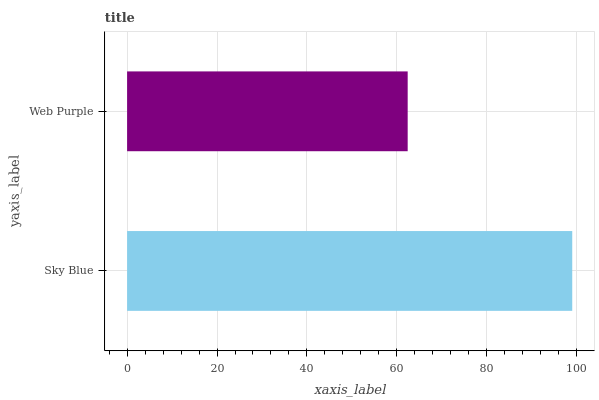Is Web Purple the minimum?
Answer yes or no. Yes. Is Sky Blue the maximum?
Answer yes or no. Yes. Is Web Purple the maximum?
Answer yes or no. No. Is Sky Blue greater than Web Purple?
Answer yes or no. Yes. Is Web Purple less than Sky Blue?
Answer yes or no. Yes. Is Web Purple greater than Sky Blue?
Answer yes or no. No. Is Sky Blue less than Web Purple?
Answer yes or no. No. Is Sky Blue the high median?
Answer yes or no. Yes. Is Web Purple the low median?
Answer yes or no. Yes. Is Web Purple the high median?
Answer yes or no. No. Is Sky Blue the low median?
Answer yes or no. No. 